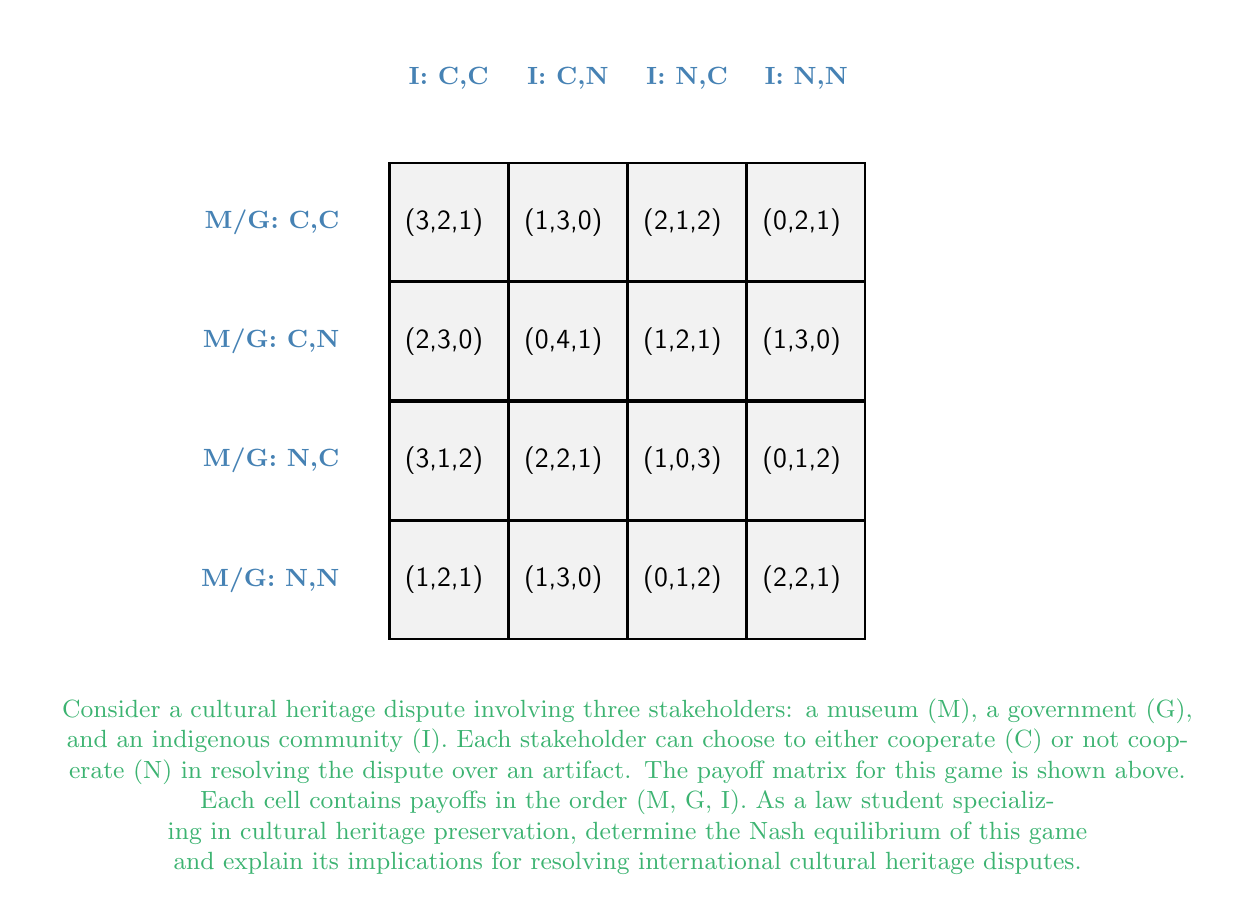Solve this math problem. To find the Nash equilibrium, we need to analyze each stakeholder's best response to the other players' strategies. Let's approach this step-by-step:

1) First, let's consider the museum (M):
   - If G and I both choose C: M's best response is C (payoff 3 vs 2)
   - If G chooses C and I chooses N: M's best response is C (payoff 1 vs 0)
   - If G chooses N and I chooses C: M's best response is C (payoff 2 vs 1)
   - If G and I both choose N: M's best response is N (payoff 2 vs 0)

2) Now, let's consider the government (G):
   - If M and I both choose C: G's best response is C (payoff 2 vs 1)
   - If M chooses C and I chooses N: G's best response is N (payoff 3 vs 2)
   - If M chooses N and I chooses C: G's best response is C (payoff 1 vs 0)
   - If M and I both choose N: G's best response is N (payoff 2 vs 1)

3) Finally, let's consider the indigenous community (I):
   - If M and G both choose C: I's best response is C (payoff 1 vs 0)
   - If M chooses C and G chooses N: I's best response is C (payoff 2 vs 1)
   - If M chooses N and G chooses C: I's best response is C (payoff 2 vs 1)
   - If M and G both choose N: I's best response is C (payoff 2 vs 1)

4) The Nash equilibrium occurs when all players are playing their best response to the other players' strategies. From our analysis, we can see that the only scenario where this occurs is when all three stakeholders choose to cooperate (C,C,C), resulting in payoffs (3,2,1).

5) This Nash equilibrium implies that in international cultural heritage disputes, cooperation among all stakeholders tends to yield the best overall outcome. The museum benefits the most (payoff 3), likely due to retaining or gaining access to the artifact. The government also benefits significantly (payoff 2), possibly from positive international relations and cultural prestige. The indigenous community, while benefiting least (payoff 1), still gains more than in most non-cooperative scenarios.

6) From a legal and cultural heritage preservation perspective, this equilibrium suggests that creating frameworks for cooperation and negotiation is crucial. It emphasizes the importance of inclusive decision-making processes that consider the interests of all stakeholders, even if the benefits are not equally distributed.

7) However, it's important to note that the lower payoff for the indigenous community in this equilibrium highlights potential power imbalances in cultural heritage disputes. This underscores the need for legal mechanisms to ensure fair representation and compensation for indigenous communities in such negotiations.
Answer: Nash equilibrium: (C,C,C) with payoffs (3,2,1) 